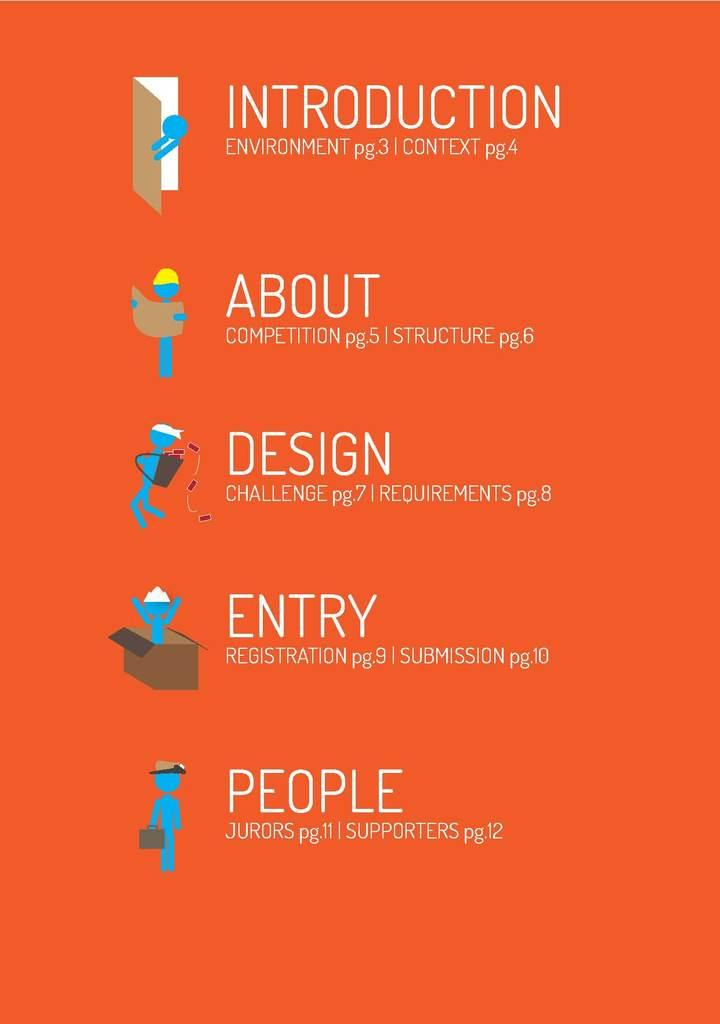<image>
Relay a brief, clear account of the picture shown. A table of contents shows each section from Introduction to People. 